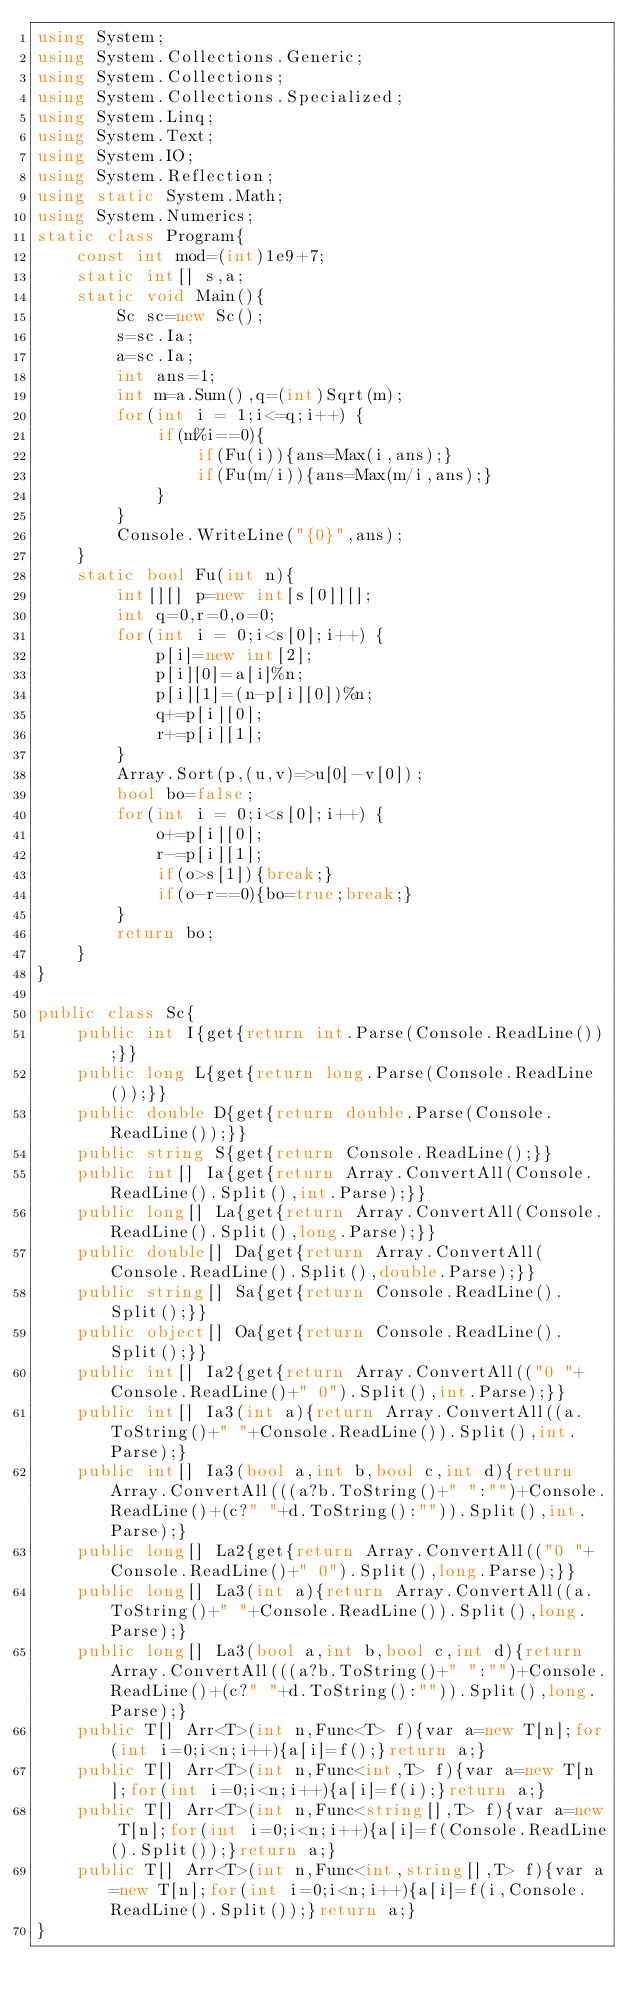<code> <loc_0><loc_0><loc_500><loc_500><_C#_>using System;
using System.Collections.Generic;
using System.Collections;
using System.Collections.Specialized;
using System.Linq;
using System.Text;
using System.IO;
using System.Reflection;
using static System.Math;
using System.Numerics;
static class Program{
	const int mod=(int)1e9+7;
	static int[] s,a;
	static void Main(){
		Sc sc=new Sc();
		s=sc.Ia;
		a=sc.Ia;
		int ans=1;
		int m=a.Sum(),q=(int)Sqrt(m);
		for(int i = 1;i<=q;i++) {
			if(m%i==0){
				if(Fu(i)){ans=Max(i,ans);}
				if(Fu(m/i)){ans=Max(m/i,ans);}
			}
		}
		Console.WriteLine("{0}",ans);
	}
	static bool Fu(int n){
		int[][] p=new int[s[0]][];
		int q=0,r=0,o=0;
		for(int i = 0;i<s[0];i++) {
			p[i]=new int[2];
			p[i][0]=a[i]%n;
			p[i][1]=(n-p[i][0])%n;
			q+=p[i][0];
			r+=p[i][1];
		}
		Array.Sort(p,(u,v)=>u[0]-v[0]);
		bool bo=false;
		for(int i = 0;i<s[0];i++) {
			o+=p[i][0];
			r-=p[i][1];
			if(o>s[1]){break;}
			if(o-r==0){bo=true;break;}
		}
		return bo;
	}
}

public class Sc{
	public int I{get{return int.Parse(Console.ReadLine());}}
	public long L{get{return long.Parse(Console.ReadLine());}}
	public double D{get{return double.Parse(Console.ReadLine());}}
	public string S{get{return Console.ReadLine();}}
	public int[] Ia{get{return Array.ConvertAll(Console.ReadLine().Split(),int.Parse);}}
	public long[] La{get{return Array.ConvertAll(Console.ReadLine().Split(),long.Parse);}}
	public double[] Da{get{return Array.ConvertAll(Console.ReadLine().Split(),double.Parse);}}
	public string[] Sa{get{return Console.ReadLine().Split();}}
	public object[] Oa{get{return Console.ReadLine().Split();}}
	public int[] Ia2{get{return Array.ConvertAll(("0 "+Console.ReadLine()+" 0").Split(),int.Parse);}}
	public int[] Ia3(int a){return Array.ConvertAll((a.ToString()+" "+Console.ReadLine()).Split(),int.Parse);}
	public int[] Ia3(bool a,int b,bool c,int d){return Array.ConvertAll(((a?b.ToString()+" ":"")+Console.ReadLine()+(c?" "+d.ToString():"")).Split(),int.Parse);}
	public long[] La2{get{return Array.ConvertAll(("0 "+Console.ReadLine()+" 0").Split(),long.Parse);}}
	public long[] La3(int a){return Array.ConvertAll((a.ToString()+" "+Console.ReadLine()).Split(),long.Parse);}
	public long[] La3(bool a,int b,bool c,int d){return Array.ConvertAll(((a?b.ToString()+" ":"")+Console.ReadLine()+(c?" "+d.ToString():"")).Split(),long.Parse);}
	public T[] Arr<T>(int n,Func<T> f){var a=new T[n];for(int i=0;i<n;i++){a[i]=f();}return a;}
	public T[] Arr<T>(int n,Func<int,T> f){var a=new T[n];for(int i=0;i<n;i++){a[i]=f(i);}return a;}
	public T[] Arr<T>(int n,Func<string[],T> f){var a=new T[n];for(int i=0;i<n;i++){a[i]=f(Console.ReadLine().Split());}return a;}
	public T[] Arr<T>(int n,Func<int,string[],T> f){var a=new T[n];for(int i=0;i<n;i++){a[i]=f(i,Console.ReadLine().Split());}return a;}
}</code> 